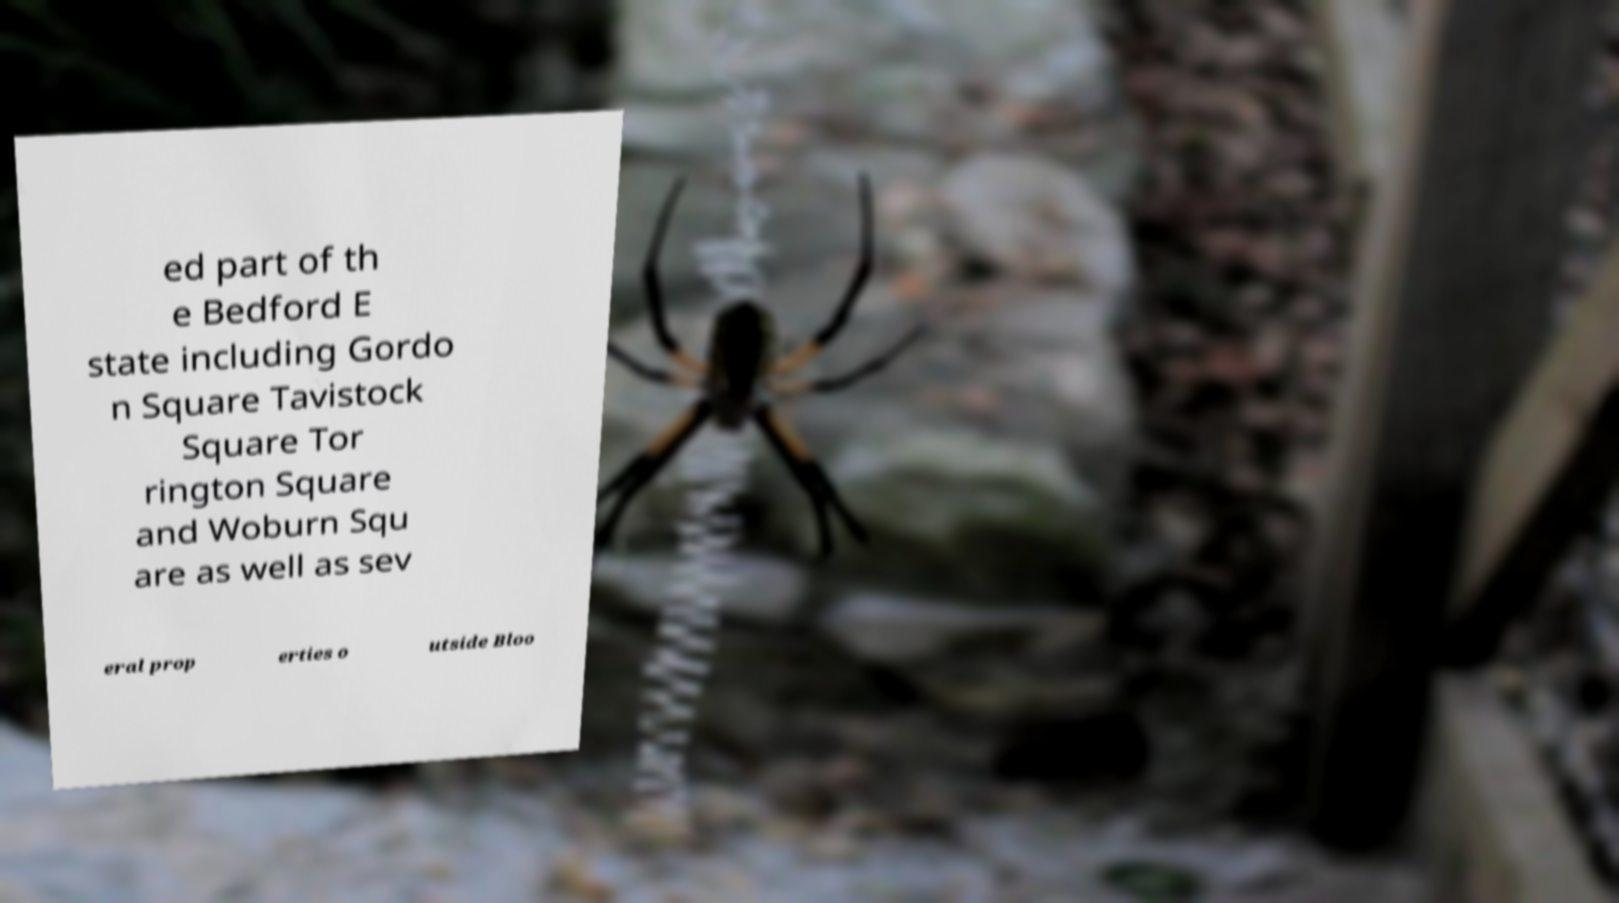I need the written content from this picture converted into text. Can you do that? ed part of th e Bedford E state including Gordo n Square Tavistock Square Tor rington Square and Woburn Squ are as well as sev eral prop erties o utside Bloo 